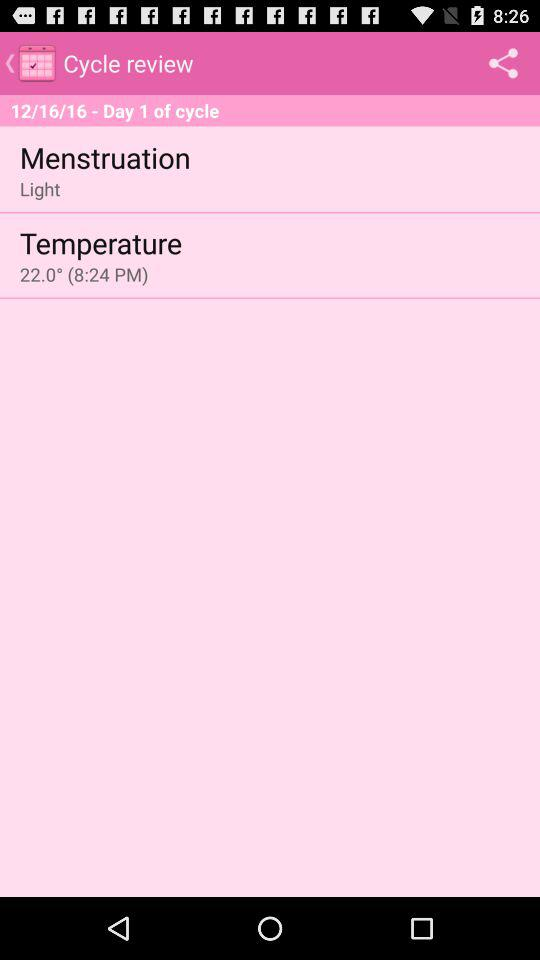What is the temperature? The temperature is 22°. 